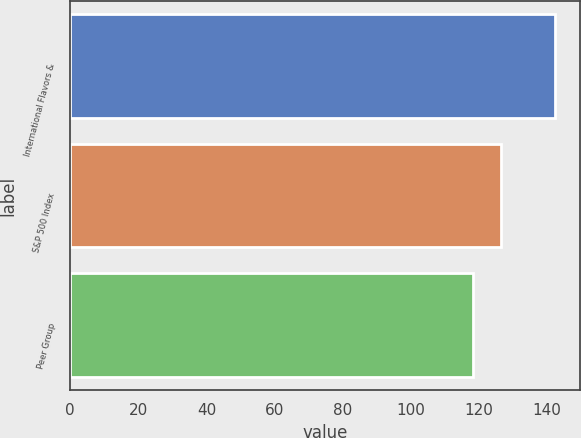<chart> <loc_0><loc_0><loc_500><loc_500><bar_chart><fcel>International Flavors &<fcel>S&P 500 Index<fcel>Peer Group<nl><fcel>142.41<fcel>126.46<fcel>118.21<nl></chart> 